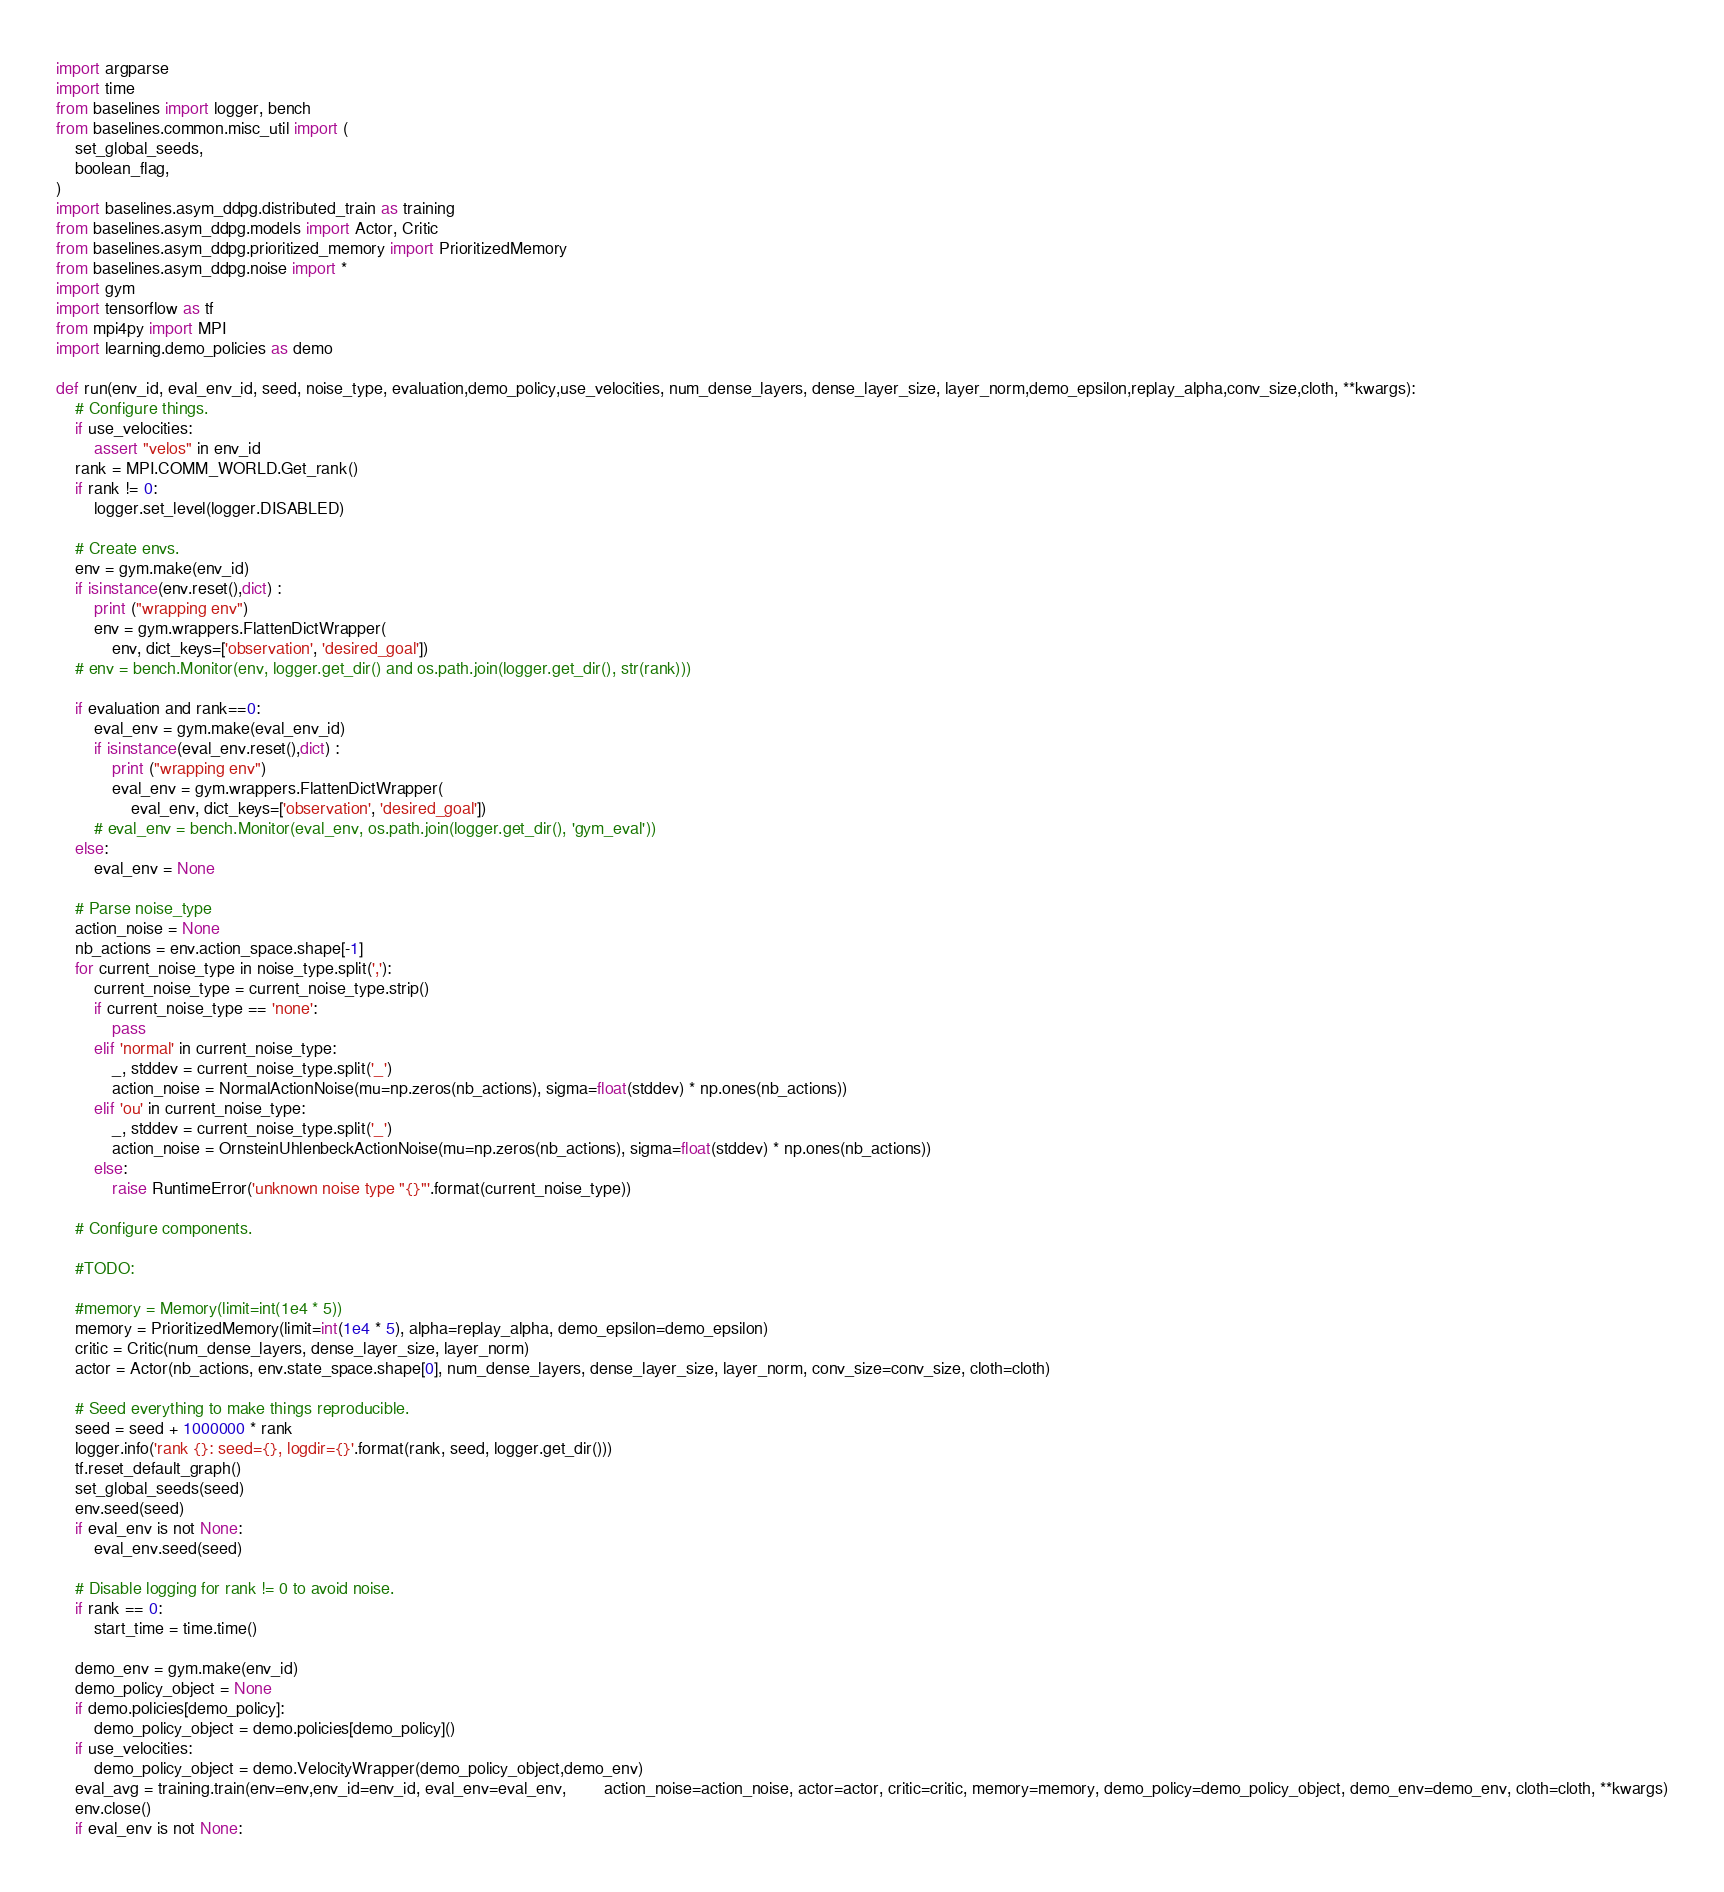<code> <loc_0><loc_0><loc_500><loc_500><_Python_>import argparse
import time
from baselines import logger, bench
from baselines.common.misc_util import (
    set_global_seeds,
    boolean_flag,
)
import baselines.asym_ddpg.distributed_train as training
from baselines.asym_ddpg.models import Actor, Critic
from baselines.asym_ddpg.prioritized_memory import PrioritizedMemory
from baselines.asym_ddpg.noise import *
import gym
import tensorflow as tf
from mpi4py import MPI
import learning.demo_policies as demo

def run(env_id, eval_env_id, seed, noise_type, evaluation,demo_policy,use_velocities, num_dense_layers, dense_layer_size, layer_norm,demo_epsilon,replay_alpha,conv_size,cloth, **kwargs):
    # Configure things.
    if use_velocities:
        assert "velos" in env_id
    rank = MPI.COMM_WORLD.Get_rank()
    if rank != 0:
        logger.set_level(logger.DISABLED)

    # Create envs.
    env = gym.make(env_id)
    if isinstance(env.reset(),dict) :
        print ("wrapping env")
        env = gym.wrappers.FlattenDictWrapper(
            env, dict_keys=['observation', 'desired_goal'])
    # env = bench.Monitor(env, logger.get_dir() and os.path.join(logger.get_dir(), str(rank)))

    if evaluation and rank==0:
        eval_env = gym.make(eval_env_id)
        if isinstance(eval_env.reset(),dict) :
            print ("wrapping env")
            eval_env = gym.wrappers.FlattenDictWrapper(
                eval_env, dict_keys=['observation', 'desired_goal'])
        # eval_env = bench.Monitor(eval_env, os.path.join(logger.get_dir(), 'gym_eval'))
    else:
        eval_env = None

    # Parse noise_type
    action_noise = None
    nb_actions = env.action_space.shape[-1]
    for current_noise_type in noise_type.split(','):
        current_noise_type = current_noise_type.strip()
        if current_noise_type == 'none':
            pass
        elif 'normal' in current_noise_type:
            _, stddev = current_noise_type.split('_')
            action_noise = NormalActionNoise(mu=np.zeros(nb_actions), sigma=float(stddev) * np.ones(nb_actions))
        elif 'ou' in current_noise_type:
            _, stddev = current_noise_type.split('_')
            action_noise = OrnsteinUhlenbeckActionNoise(mu=np.zeros(nb_actions), sigma=float(stddev) * np.ones(nb_actions))
        else:
            raise RuntimeError('unknown noise type "{}"'.format(current_noise_type))

    # Configure components.

    #TODO:

    #memory = Memory(limit=int(1e4 * 5))
    memory = PrioritizedMemory(limit=int(1e4 * 5), alpha=replay_alpha, demo_epsilon=demo_epsilon)
    critic = Critic(num_dense_layers, dense_layer_size, layer_norm)
    actor = Actor(nb_actions, env.state_space.shape[0], num_dense_layers, dense_layer_size, layer_norm, conv_size=conv_size, cloth=cloth)

    # Seed everything to make things reproducible.
    seed = seed + 1000000 * rank
    logger.info('rank {}: seed={}, logdir={}'.format(rank, seed, logger.get_dir()))
    tf.reset_default_graph()
    set_global_seeds(seed)
    env.seed(seed)
    if eval_env is not None:
        eval_env.seed(seed)

    # Disable logging for rank != 0 to avoid noise.
    if rank == 0:
        start_time = time.time()

    demo_env = gym.make(env_id)
    demo_policy_object = None
    if demo.policies[demo_policy]:
        demo_policy_object = demo.policies[demo_policy]()
    if use_velocities:
        demo_policy_object = demo.VelocityWrapper(demo_policy_object,demo_env)
    eval_avg = training.train(env=env,env_id=env_id, eval_env=eval_env,        action_noise=action_noise, actor=actor, critic=critic, memory=memory, demo_policy=demo_policy_object, demo_env=demo_env, cloth=cloth, **kwargs)
    env.close()
    if eval_env is not None:</code> 